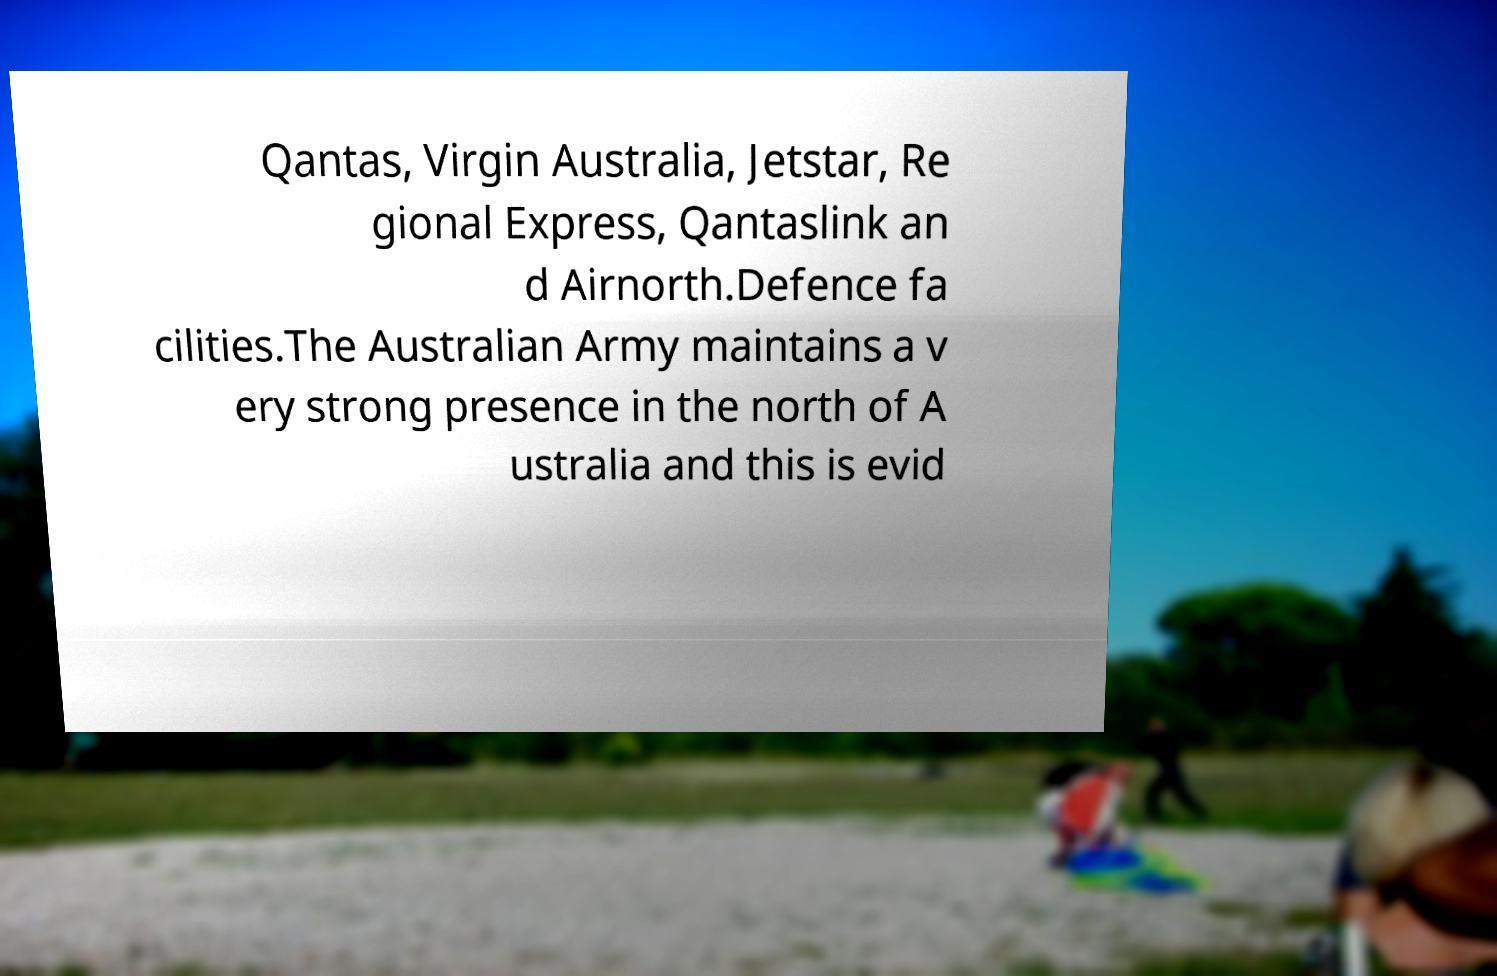Please identify and transcribe the text found in this image. Qantas, Virgin Australia, Jetstar, Re gional Express, Qantaslink an d Airnorth.Defence fa cilities.The Australian Army maintains a v ery strong presence in the north of A ustralia and this is evid 